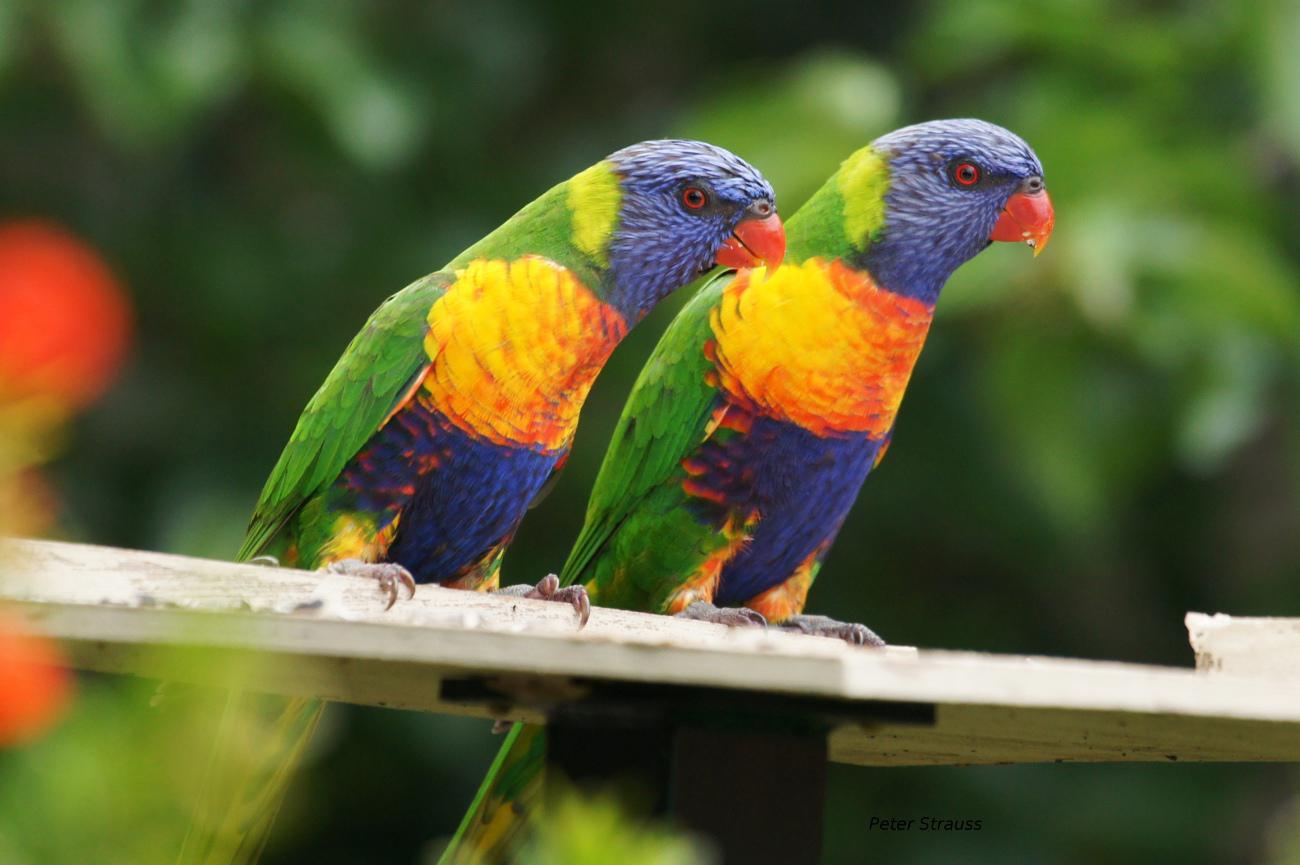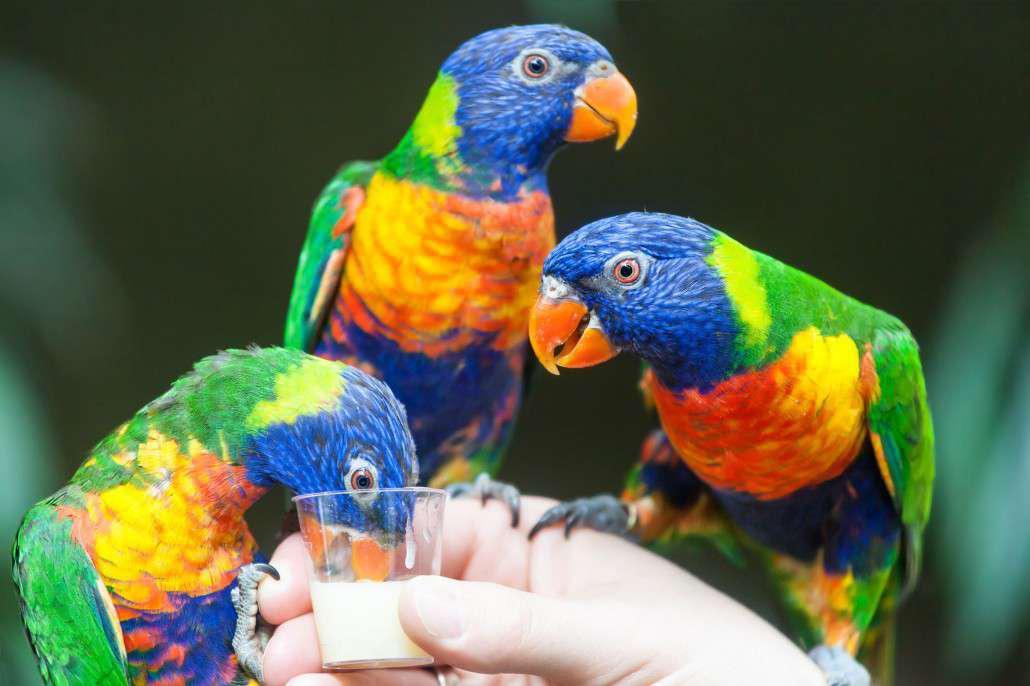The first image is the image on the left, the second image is the image on the right. Examine the images to the left and right. Is the description "There are two birds" accurate? Answer yes or no. No. 